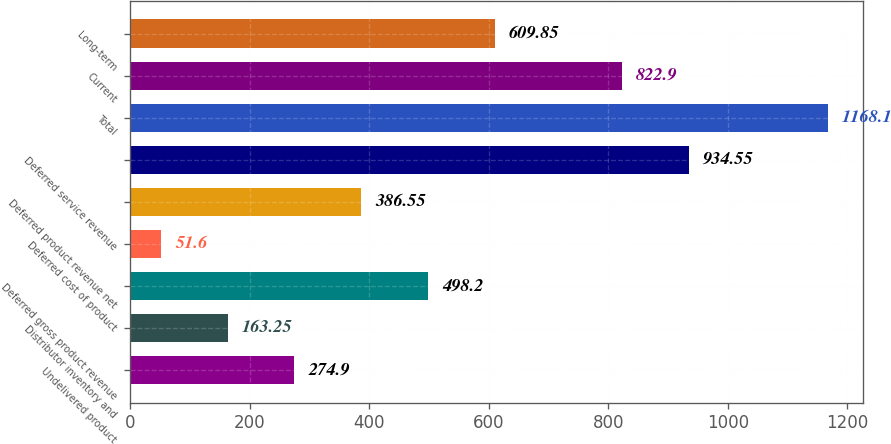<chart> <loc_0><loc_0><loc_500><loc_500><bar_chart><fcel>Undelivered product<fcel>Distributor inventory and<fcel>Deferred gross product revenue<fcel>Deferred cost of product<fcel>Deferred product revenue net<fcel>Deferred service revenue<fcel>Total<fcel>Current<fcel>Long-term<nl><fcel>274.9<fcel>163.25<fcel>498.2<fcel>51.6<fcel>386.55<fcel>934.55<fcel>1168.1<fcel>822.9<fcel>609.85<nl></chart> 